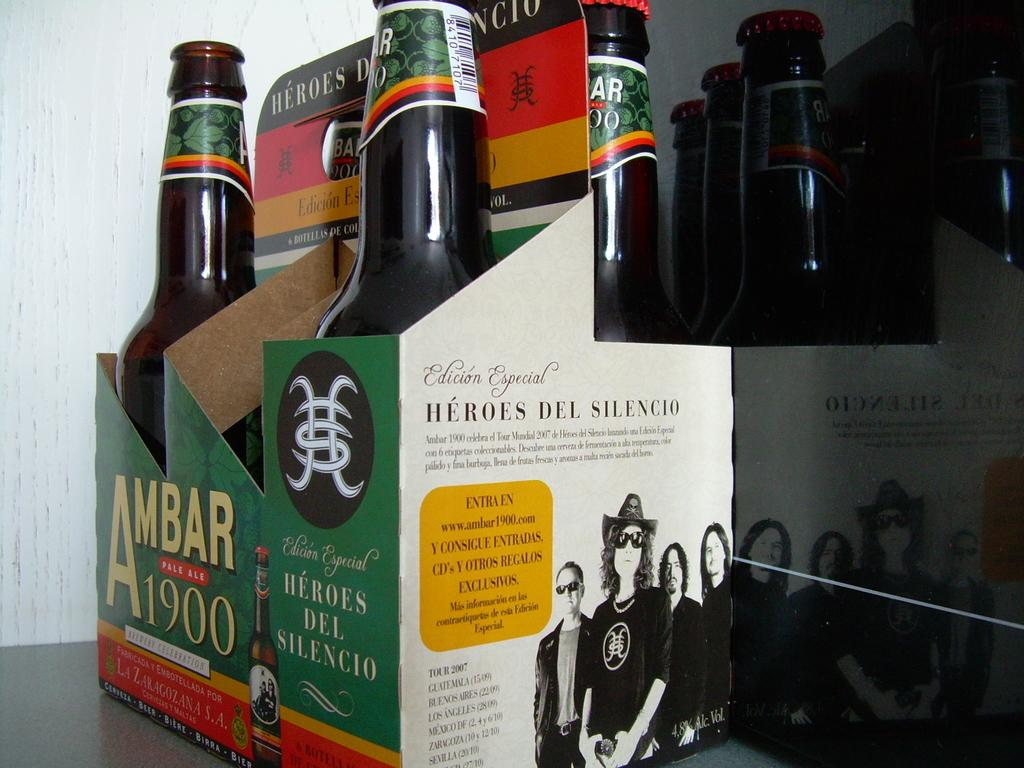What is the main subject of the image? The main subject of the image is a box containing bottles. How are the bottles arranged in the box? The bottles are arranged in a box in the center of the image. What can be seen in the background of the image? There is a wall visible in the background of the image. Can you see a monkey wearing a collar in the image? No, there is no monkey or collar present in the image. 